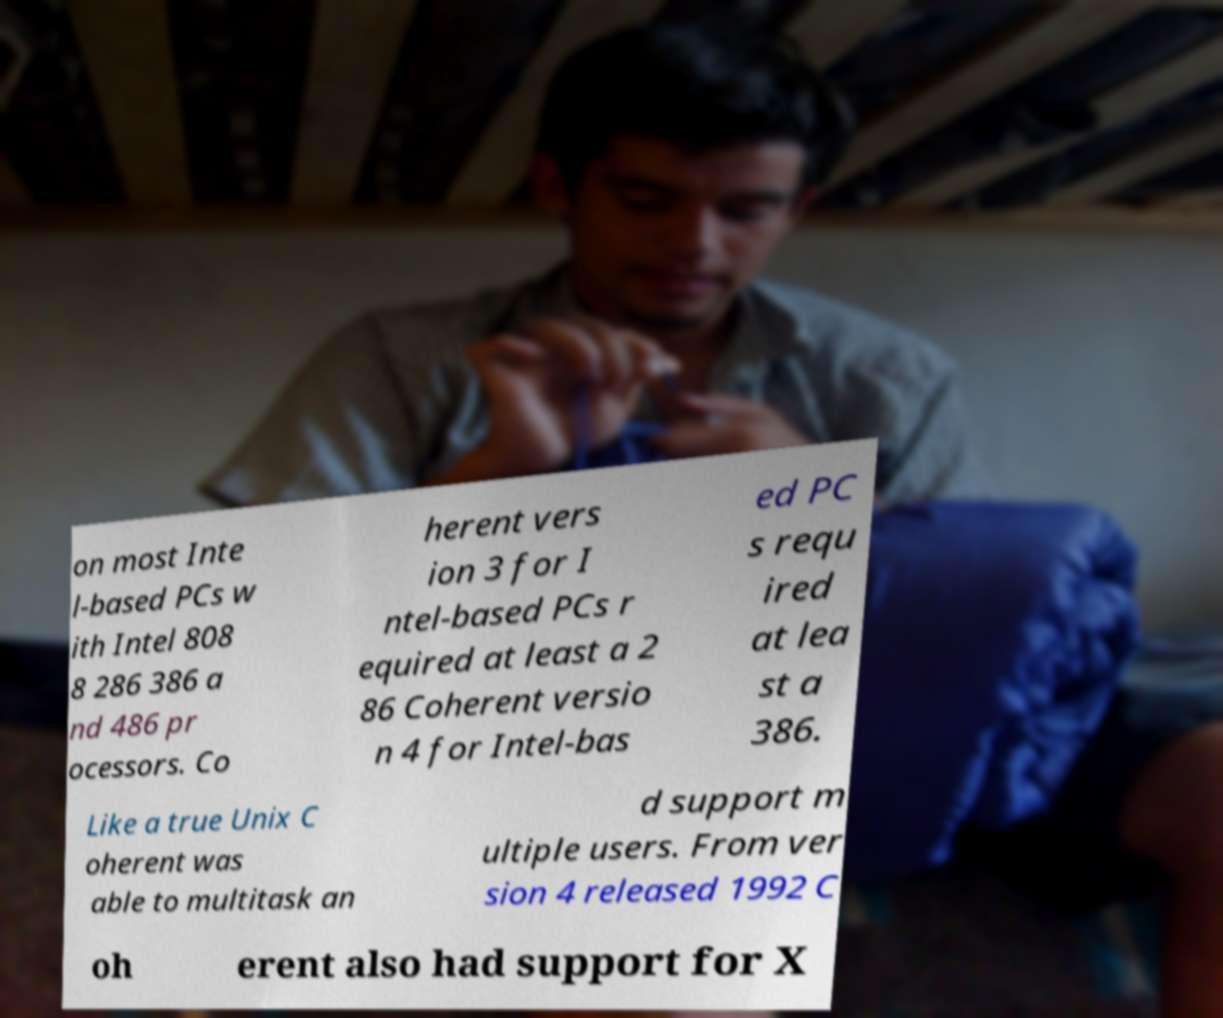For documentation purposes, I need the text within this image transcribed. Could you provide that? on most Inte l-based PCs w ith Intel 808 8 286 386 a nd 486 pr ocessors. Co herent vers ion 3 for I ntel-based PCs r equired at least a 2 86 Coherent versio n 4 for Intel-bas ed PC s requ ired at lea st a 386. Like a true Unix C oherent was able to multitask an d support m ultiple users. From ver sion 4 released 1992 C oh erent also had support for X 